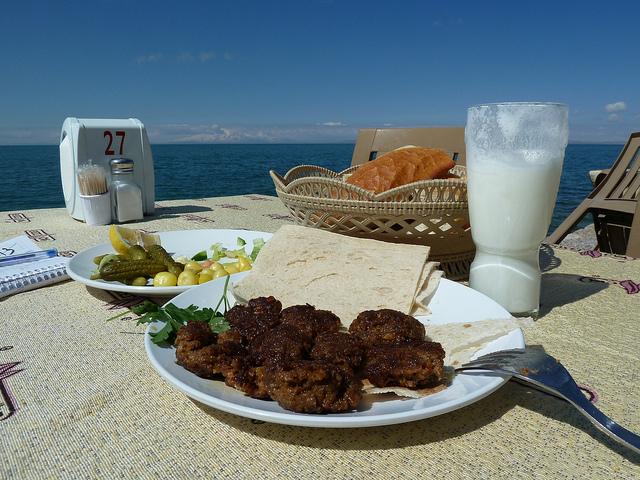What does coffee cake go well with?
Concise answer only. Coffee. Is this a park?
Write a very short answer. No. Would you have this for breakfast?
Quick response, please. Yes. What time of day is it?
Keep it brief. Afternoon. Is the glass of milk empty?
Give a very brief answer. No. Is this food delicious?
Answer briefly. Yes. 